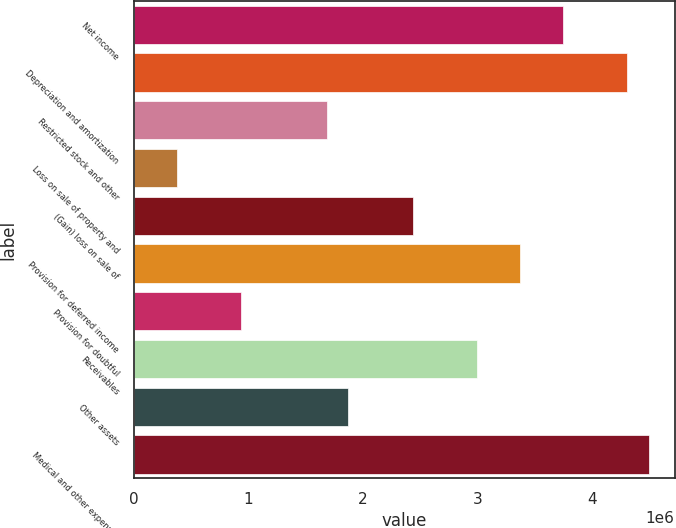<chart> <loc_0><loc_0><loc_500><loc_500><bar_chart><fcel>Net income<fcel>Depreciation and amortization<fcel>Restricted stock and other<fcel>Loss on sale of property and<fcel>(Gain) loss on sale of<fcel>Provision for deferred income<fcel>Provision for doubtful<fcel>Receivables<fcel>Other assets<fcel>Medical and other expenses<nl><fcel>3.74849e+06<fcel>4.3107e+06<fcel>1.68708e+06<fcel>375273<fcel>2.43669e+06<fcel>3.37369e+06<fcel>937476<fcel>2.99889e+06<fcel>1.87448e+06<fcel>4.4981e+06<nl></chart> 